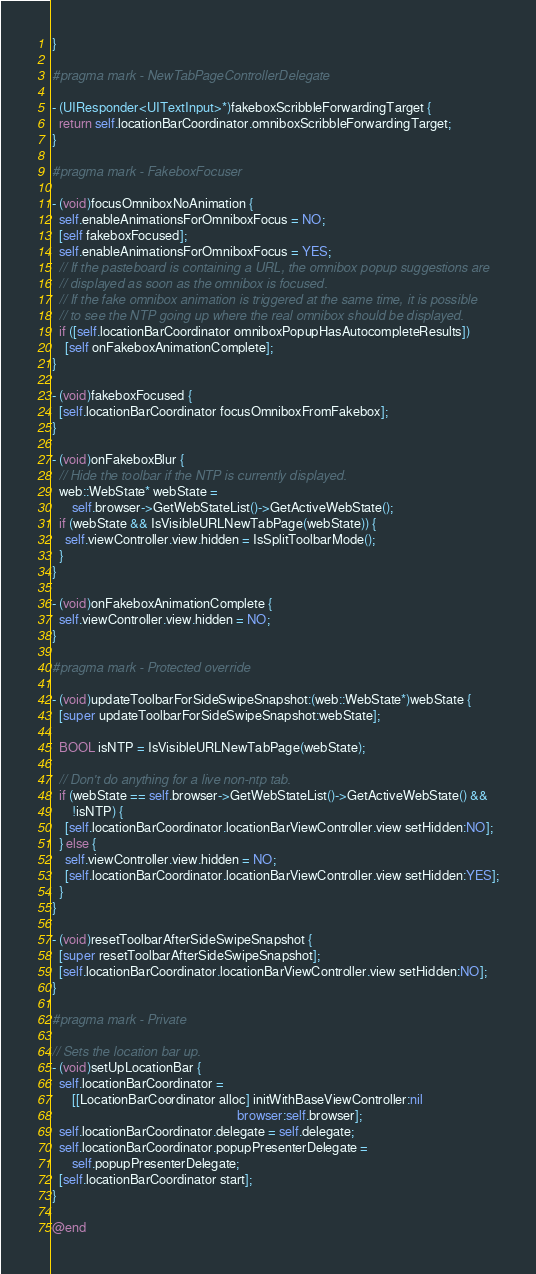Convert code to text. <code><loc_0><loc_0><loc_500><loc_500><_ObjectiveC_>}

#pragma mark - NewTabPageControllerDelegate

- (UIResponder<UITextInput>*)fakeboxScribbleForwardingTarget {
  return self.locationBarCoordinator.omniboxScribbleForwardingTarget;
}

#pragma mark - FakeboxFocuser

- (void)focusOmniboxNoAnimation {
  self.enableAnimationsForOmniboxFocus = NO;
  [self fakeboxFocused];
  self.enableAnimationsForOmniboxFocus = YES;
  // If the pasteboard is containing a URL, the omnibox popup suggestions are
  // displayed as soon as the omnibox is focused.
  // If the fake omnibox animation is triggered at the same time, it is possible
  // to see the NTP going up where the real omnibox should be displayed.
  if ([self.locationBarCoordinator omniboxPopupHasAutocompleteResults])
    [self onFakeboxAnimationComplete];
}

- (void)fakeboxFocused {
  [self.locationBarCoordinator focusOmniboxFromFakebox];
}

- (void)onFakeboxBlur {
  // Hide the toolbar if the NTP is currently displayed.
  web::WebState* webState =
      self.browser->GetWebStateList()->GetActiveWebState();
  if (webState && IsVisibleURLNewTabPage(webState)) {
    self.viewController.view.hidden = IsSplitToolbarMode();
  }
}

- (void)onFakeboxAnimationComplete {
  self.viewController.view.hidden = NO;
}

#pragma mark - Protected override

- (void)updateToolbarForSideSwipeSnapshot:(web::WebState*)webState {
  [super updateToolbarForSideSwipeSnapshot:webState];

  BOOL isNTP = IsVisibleURLNewTabPage(webState);

  // Don't do anything for a live non-ntp tab.
  if (webState == self.browser->GetWebStateList()->GetActiveWebState() &&
      !isNTP) {
    [self.locationBarCoordinator.locationBarViewController.view setHidden:NO];
  } else {
    self.viewController.view.hidden = NO;
    [self.locationBarCoordinator.locationBarViewController.view setHidden:YES];
  }
}

- (void)resetToolbarAfterSideSwipeSnapshot {
  [super resetToolbarAfterSideSwipeSnapshot];
  [self.locationBarCoordinator.locationBarViewController.view setHidden:NO];
}

#pragma mark - Private

// Sets the location bar up.
- (void)setUpLocationBar {
  self.locationBarCoordinator =
      [[LocationBarCoordinator alloc] initWithBaseViewController:nil
                                                         browser:self.browser];
  self.locationBarCoordinator.delegate = self.delegate;
  self.locationBarCoordinator.popupPresenterDelegate =
      self.popupPresenterDelegate;
  [self.locationBarCoordinator start];
}

@end
</code> 